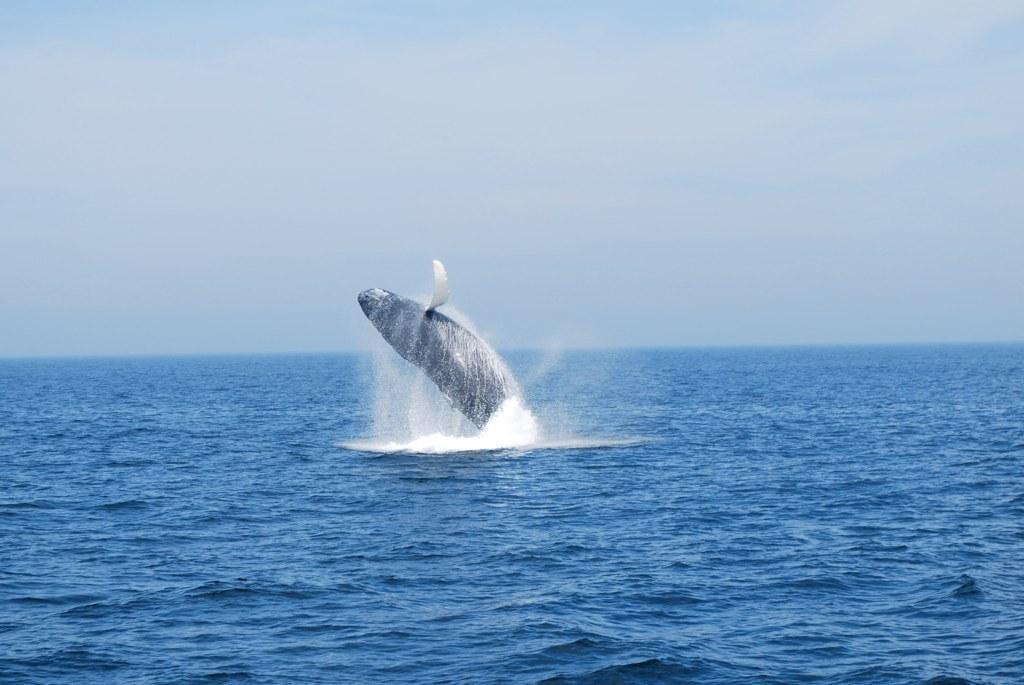Please provide a concise description of this image. In this image I can see water and a whale. In the background I can see the sky. 